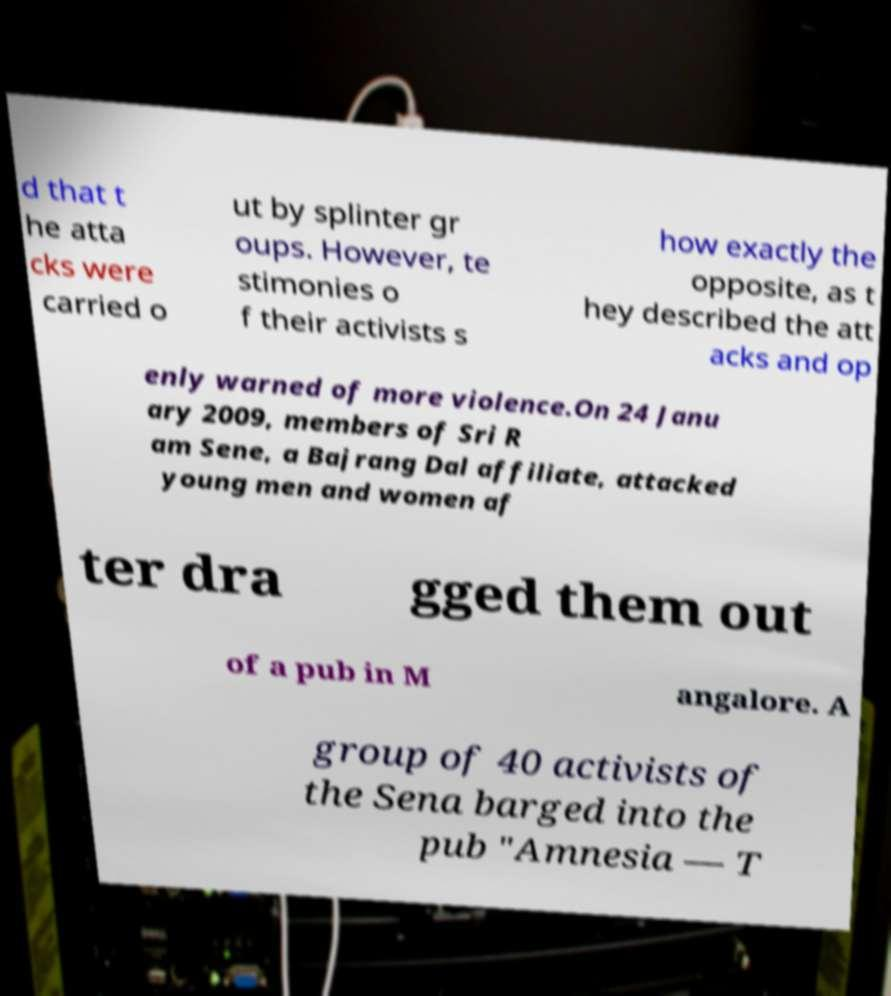Please read and relay the text visible in this image. What does it say? d that t he atta cks were carried o ut by splinter gr oups. However, te stimonies o f their activists s how exactly the opposite, as t hey described the att acks and op enly warned of more violence.On 24 Janu ary 2009, members of Sri R am Sene, a Bajrang Dal affiliate, attacked young men and women af ter dra gged them out of a pub in M angalore. A group of 40 activists of the Sena barged into the pub "Amnesia — T 